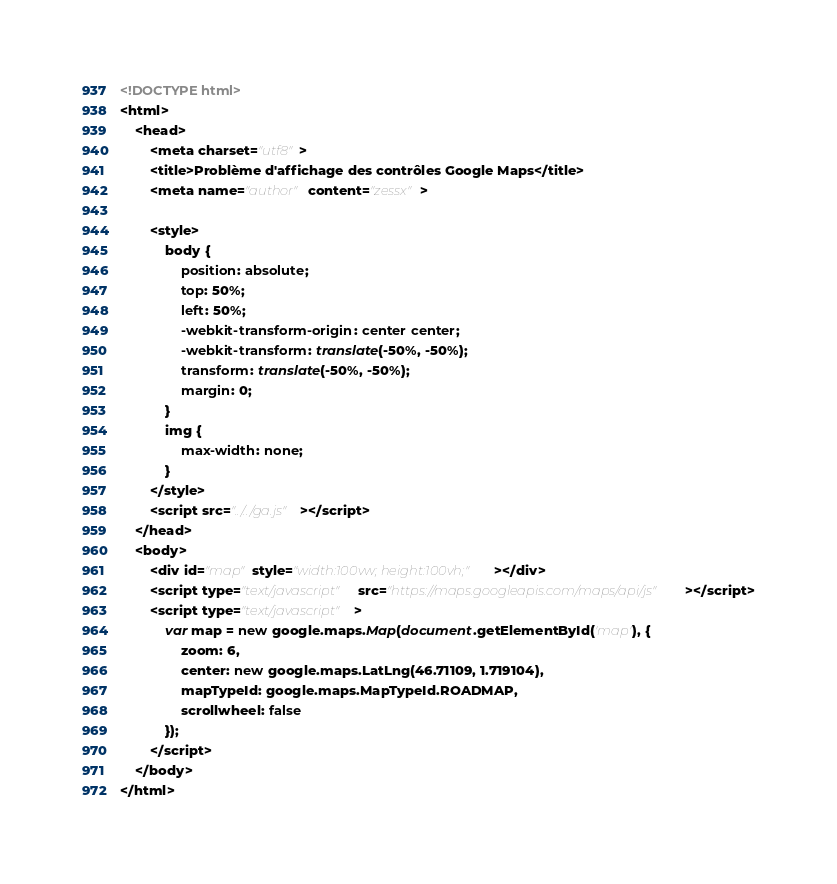Convert code to text. <code><loc_0><loc_0><loc_500><loc_500><_HTML_><!DOCTYPE html>
<html>
    <head>
        <meta charset="utf8">
        <title>Problème d'affichage des contrôles Google Maps</title>
        <meta name="author" content="zessx">

        <style>
            body {
                position: absolute;
                top: 50%;
                left: 50%;
                -webkit-transform-origin: center center;
                -webkit-transform: translate(-50%, -50%);
                transform: translate(-50%, -50%);
                margin: 0;
            }
            img {
                max-width: none;
            }
        </style>
        <script src="../../ga.js"></script>
    </head>
    <body>
        <div id="map" style="width:100vw; height:100vh;"></div>
        <script type="text/javascript" src="https://maps.googleapis.com/maps/api/js"></script>
        <script type="text/javascript">
            var map = new google.maps.Map(document.getElementById('map'), {
                zoom: 6,
                center: new google.maps.LatLng(46.71109, 1.719104),
                mapTypeId: google.maps.MapTypeId.ROADMAP,
                scrollwheel: false
            });
        </script>
    </body>
</html></code> 